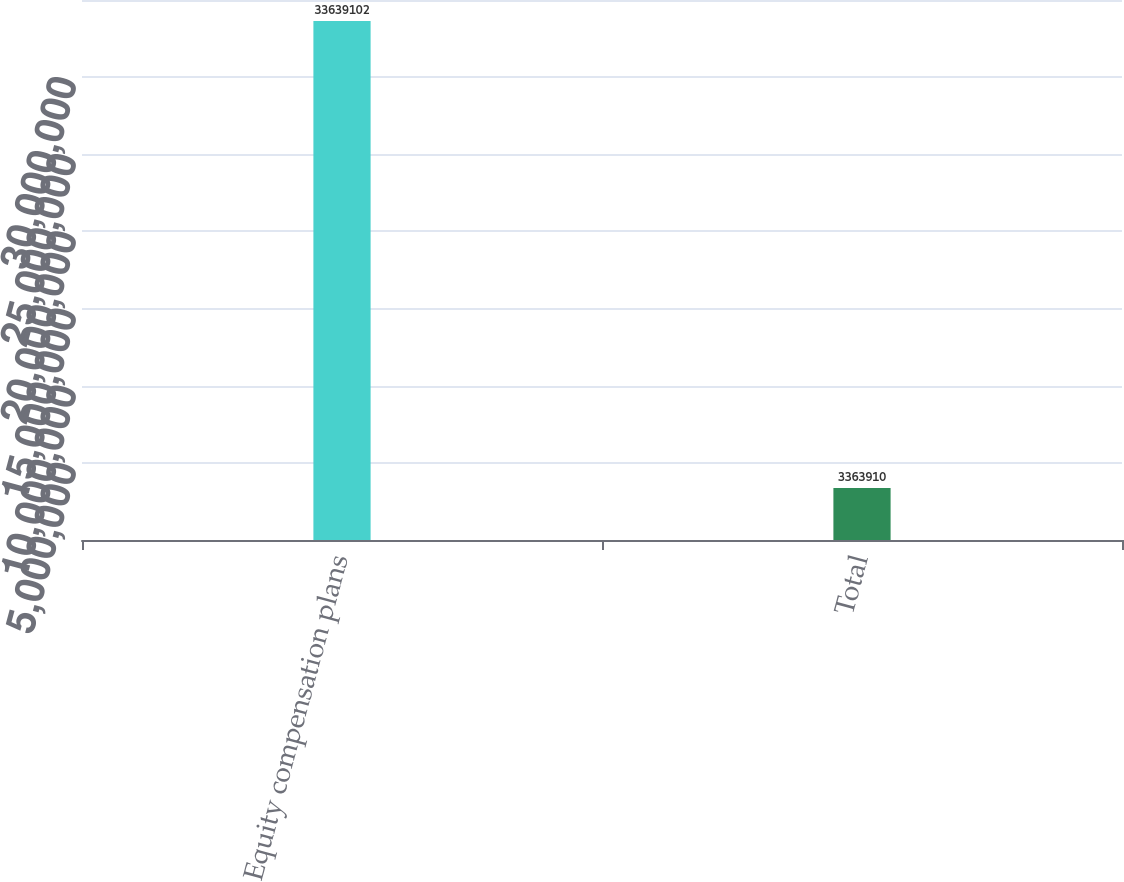Convert chart to OTSL. <chart><loc_0><loc_0><loc_500><loc_500><bar_chart><fcel>Equity compensation plans<fcel>Total<nl><fcel>3.36391e+07<fcel>3.36391e+06<nl></chart> 